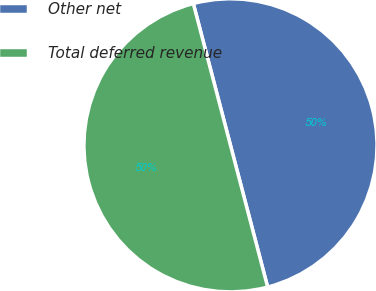Convert chart to OTSL. <chart><loc_0><loc_0><loc_500><loc_500><pie_chart><fcel>Other net<fcel>Total deferred revenue<nl><fcel>50.0%<fcel>50.0%<nl></chart> 